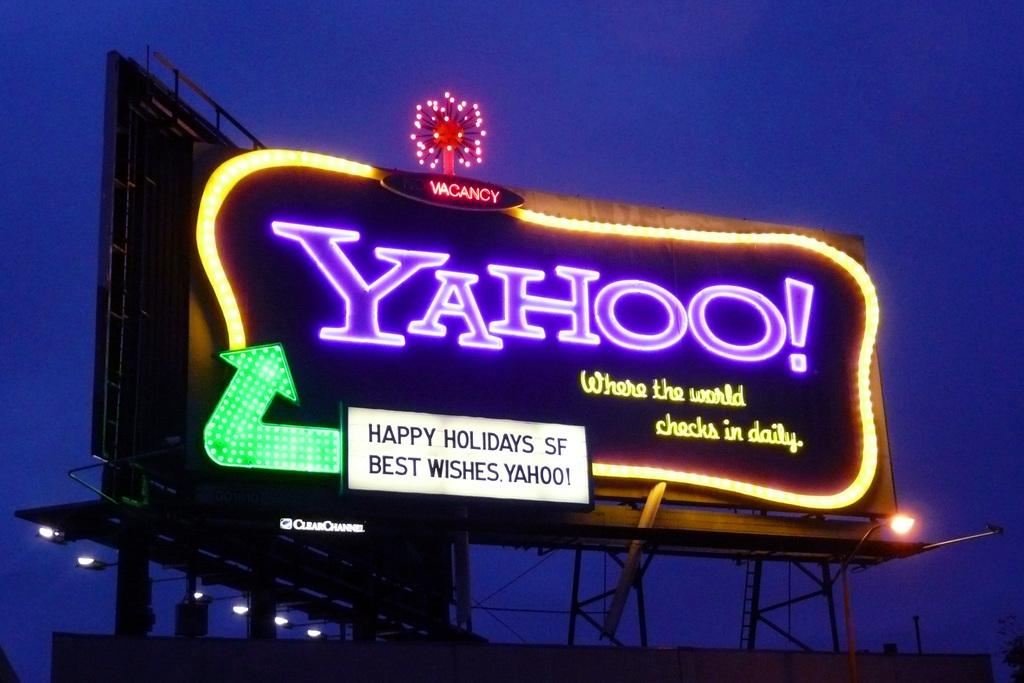What famous search engine is named here?
Provide a short and direct response. Yahoo. What are they wishing you?
Offer a very short reply. Happy holidays. 